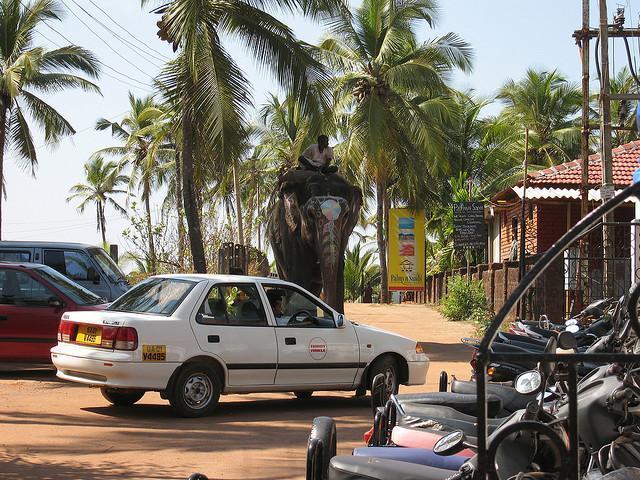How many motorcycles are there?
Give a very brief answer. 2. How many cars are visible?
Give a very brief answer. 3. 